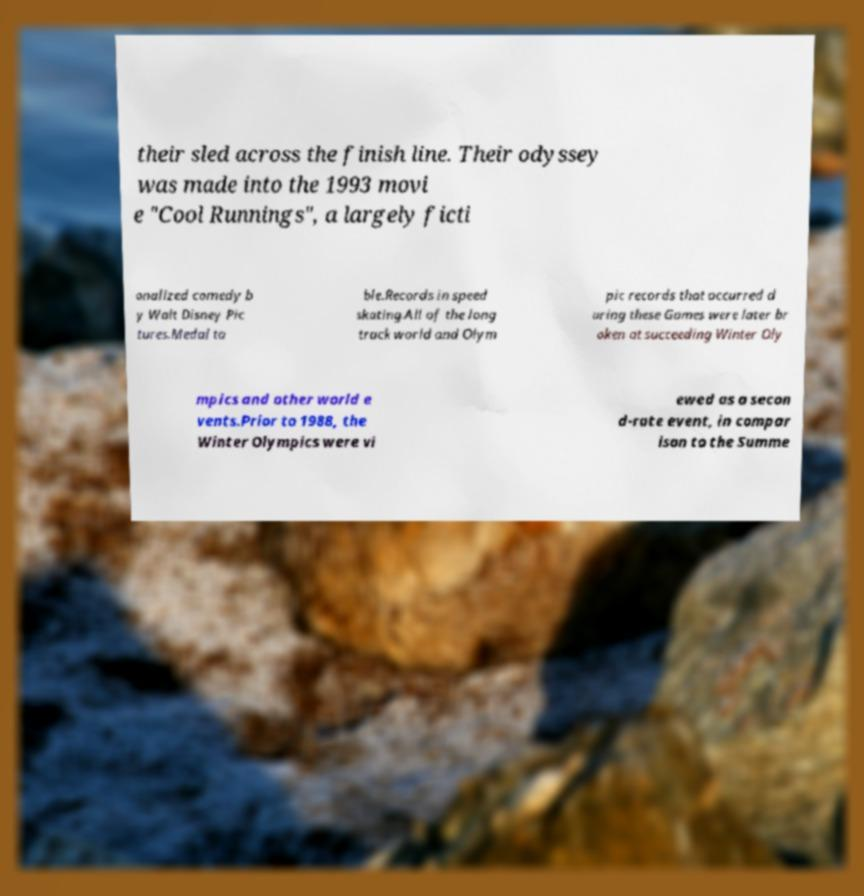Can you accurately transcribe the text from the provided image for me? their sled across the finish line. Their odyssey was made into the 1993 movi e "Cool Runnings", a largely ficti onalized comedy b y Walt Disney Pic tures.Medal ta ble.Records in speed skating.All of the long track world and Olym pic records that occurred d uring these Games were later br oken at succeeding Winter Oly mpics and other world e vents.Prior to 1988, the Winter Olympics were vi ewed as a secon d-rate event, in compar ison to the Summe 